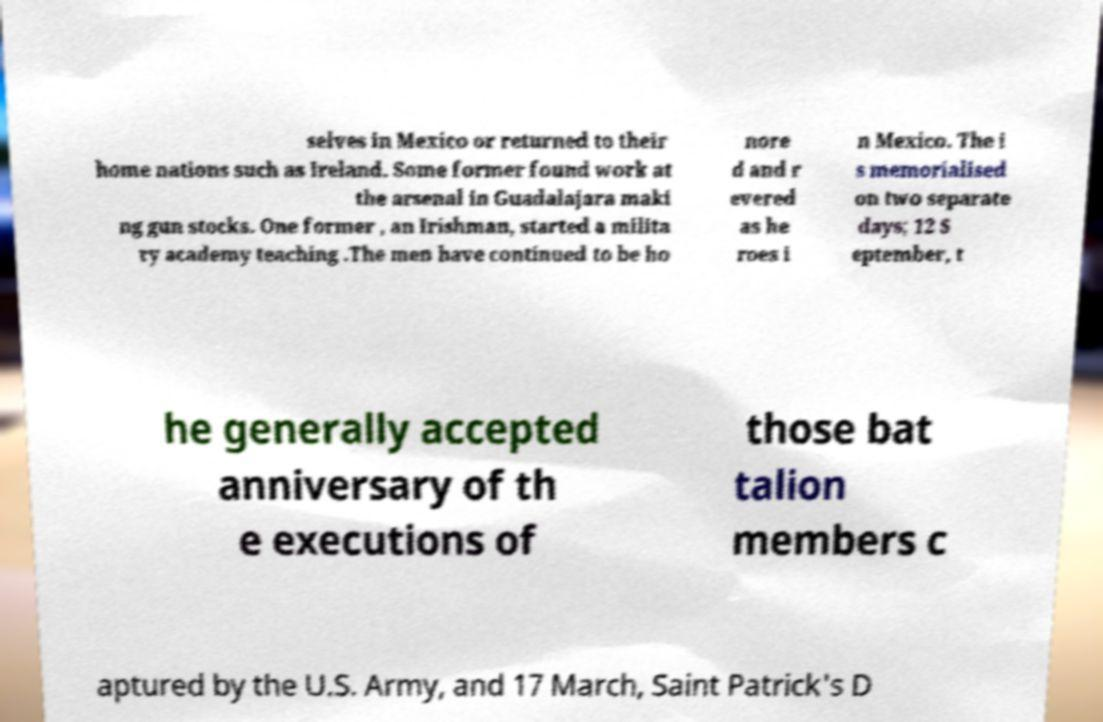Can you read and provide the text displayed in the image?This photo seems to have some interesting text. Can you extract and type it out for me? selves in Mexico or returned to their home nations such as Ireland. Some former found work at the arsenal in Guadalajara maki ng gun stocks. One former , an Irishman, started a milita ry academy teaching .The men have continued to be ho nore d and r evered as he roes i n Mexico. The i s memorialised on two separate days; 12 S eptember, t he generally accepted anniversary of th e executions of those bat talion members c aptured by the U.S. Army, and 17 March, Saint Patrick's D 